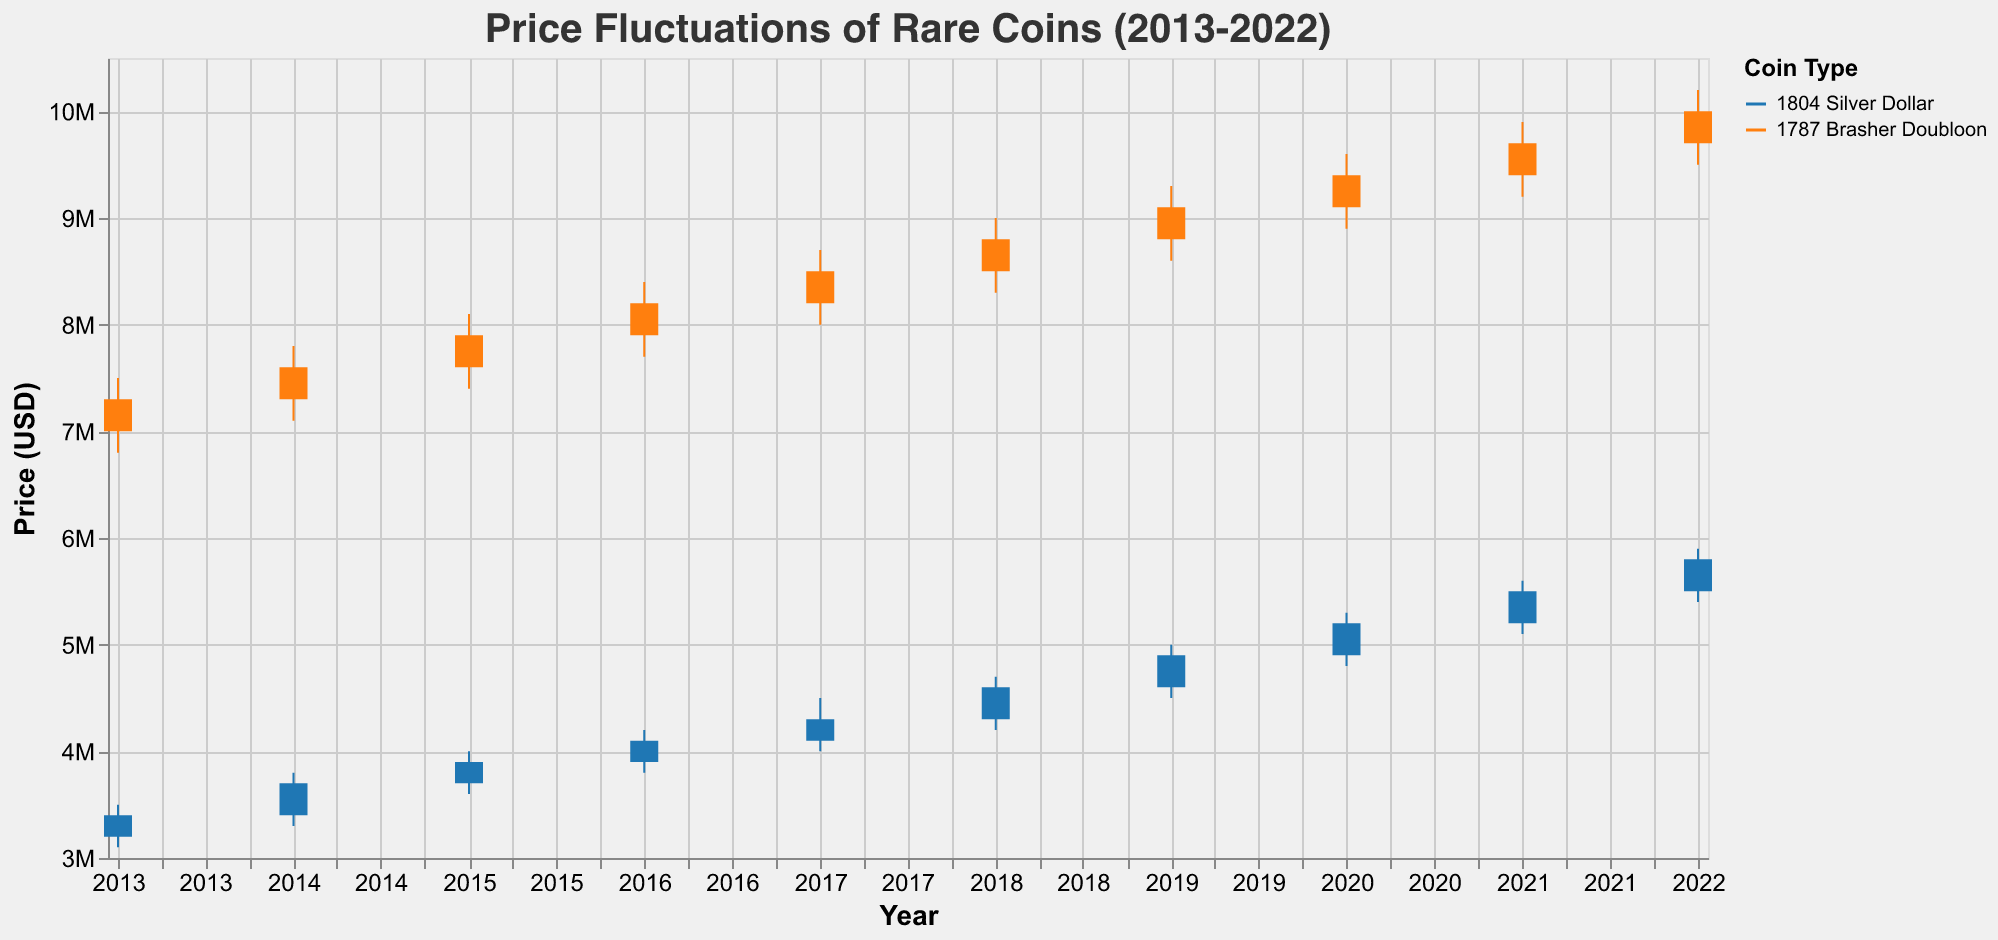Which coin has the highest closing price in 2022? The closing price can be found on the y-axis, and the specific year can be identified on the x-axis. For 2022, the 1787 Brasher Doubloon closes at $10,000,000, while the 1804 Silver Dollar closes at $5,800,000.
Answer: 1787 Brasher Doubloon What is the highest price reached by the 1804 Silver Dollar across all years? By examining the highest points of the vertical lines representing the high prices for the 1804 Silver Dollar over the entire period, the highest value is $5,900,000 in 2022.
Answer: $5,900,000 How does the closing price of the 1787 Brasher Doubloon in 2013 compare with its opening price in 2014? In 2013, the closing price for the 1787 Brasher Doubloon is $7,300,000, and the 2014 opening price is $7,300,000, so they are equal.
Answer: Equal What is the average closing price of the 1804 Silver Dollar from 2020 to 2022? Calculate the sum of closing prices from 2020 to 2022 ($5,200,000 in 2020, $5,500,000 in 2021, and $5,800,000 in 2022), then divide by the number of years (3). The sum is ($5,200,000 + $5,500,000 + $5,800,000) = $16,500,000, and the average is $16,500,000 / 3 = $5,500,000.
Answer: $5,500,000 Which coin shows a more consistent increase in closing prices from 2013 to 2022? By observing the trends in the closing prices, the 1787 Brasher Doubloon shows a steady linear increase every year, while the 1804 Silver Dollar also increases but with more fluctuation in the rate of increase.
Answer: 1787 Brasher Doubloon What was the lowest price of the 1787 Brasher Doubloon in 2016? Find the lowest point reached by the vertical line in 2016 for the 1787 Brasher Doubloon, which is $7,700,000.
Answer: $7,700,000 Between 2017 and 2020, which coin had the largest single-year closing price increase? Calculate the closing price differences year-over-year for both coins. The largest increase observed is the 1804 Silver Dollar from 2019 to 2020, increasing from $4,900,000 to $5,200,000 ($300,000).
Answer: 1804 Silver Dollar Was the opening price higher than the closing price for the 1804 Silver Dollar in any year? Compare the opening and closing prices across all years. The opening price is never higher than the closing price for the 1804 Silver Dollar in any year.
Answer: No What was the percentage increase in the closing price of the 1787 Brasher Doubloon from 2013 to 2022? Calculate the percentage increase based on the initial value in 2013 ($7,300,000) and the final value in 2022 ($10,000,000). Percentage increase = [(10,000,000 - 7,300,000) / 7,300,000] * 100 = 37%.
Answer: 37% Which coin had more volatility in terms of the range between high and low prices in 2017? The range is calculated by subtracting the low price from the high price. For the 1804 Silver Dollar in 2017, the range is $4,500,000 - $4,000,000 = $500,000. For the 1787 Brasher Doubloon, the range is $8,700,000 - $8,000,000 = $700,000. Therefore, the 1787 Brasher Doubloon had more volatility.
Answer: 1787 Brasher Doubloon 